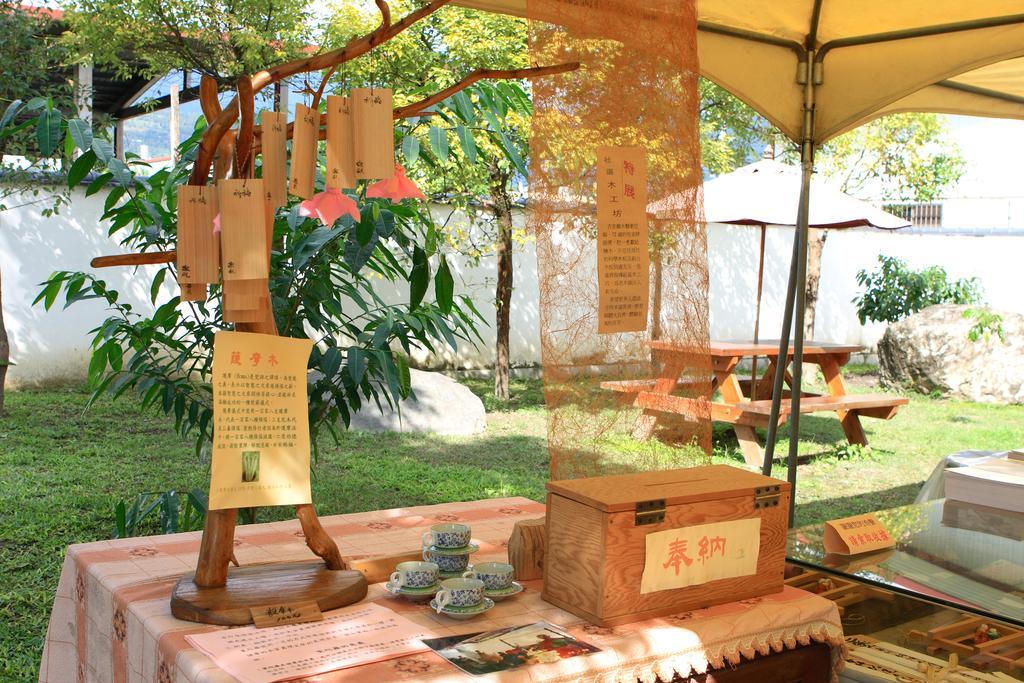Could you give a brief overview of what you see in this image? Here we can see a wooden box and cups and some thing made of wood placed on a table and there are umbrellas present here and there, there is bench to sit, there are plants and trees 